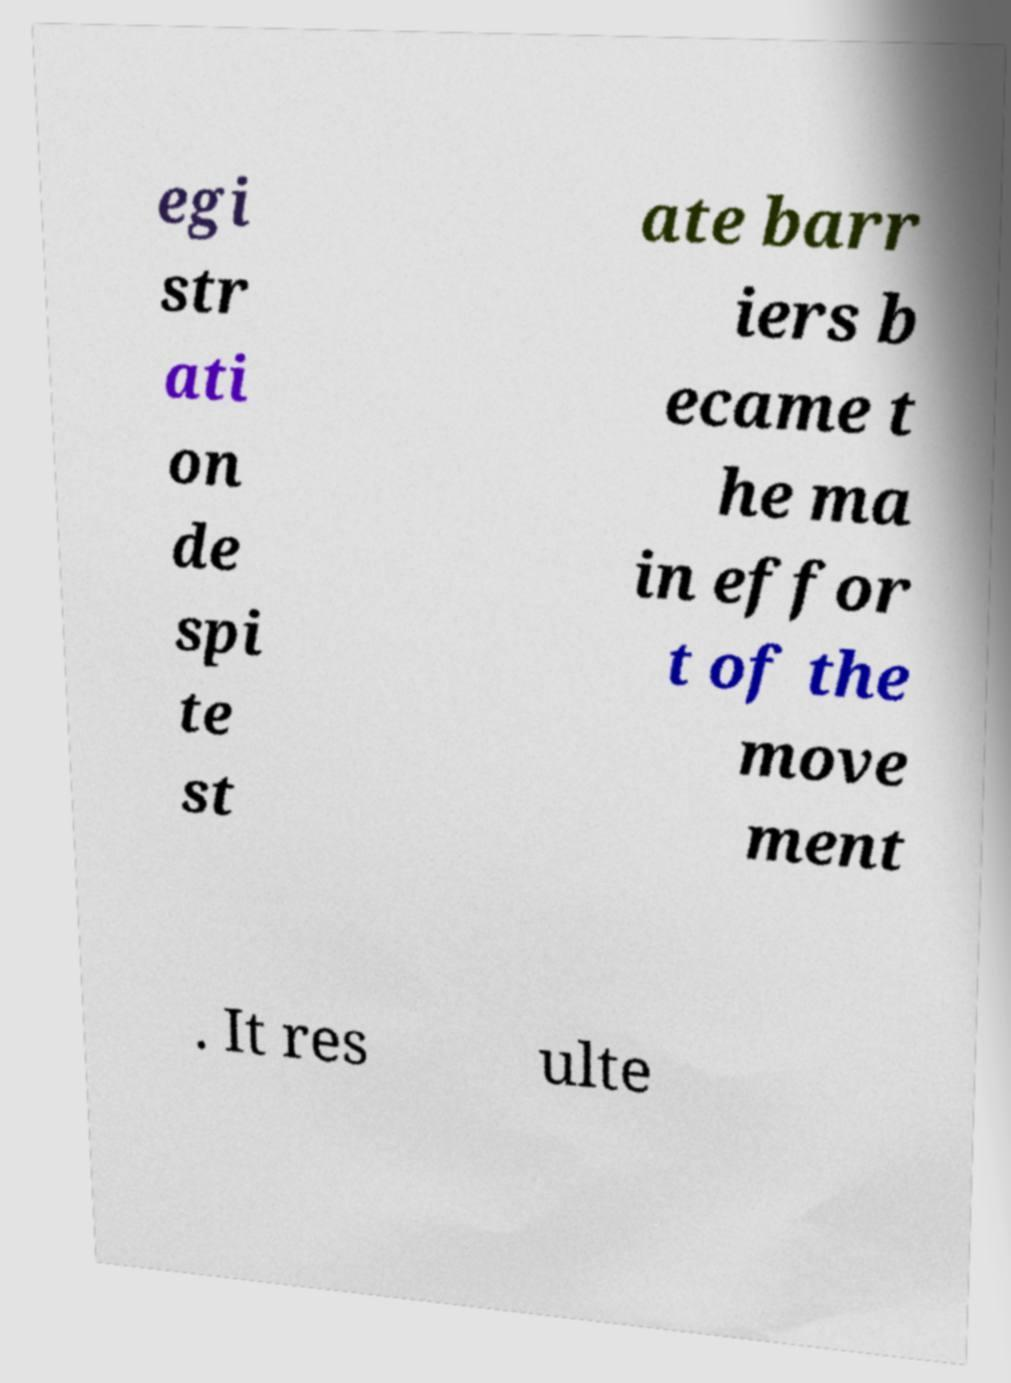Could you assist in decoding the text presented in this image and type it out clearly? egi str ati on de spi te st ate barr iers b ecame t he ma in effor t of the move ment . It res ulte 